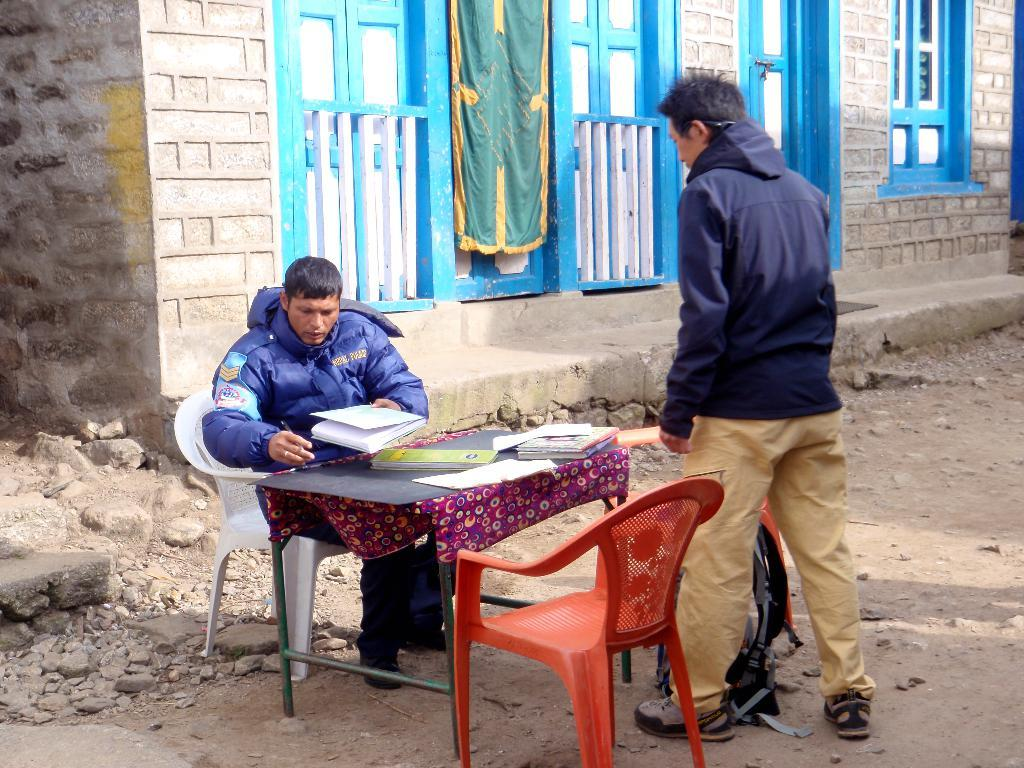What is the person in the image wearing? The person in the image is wearing a blue jacket. What is the person doing in the image? The person is sitting in a chair. What is in front of the person sitting in the chair? There is a table in front of the person sitting in the chair. What can be found on the table? The table has books on it. Who is present in the image besides the person sitting in the chair? There is another person standing in front of the person sitting in the chair. What type of arch can be seen in the background of the image? There is no arch visible in the background of the image. 